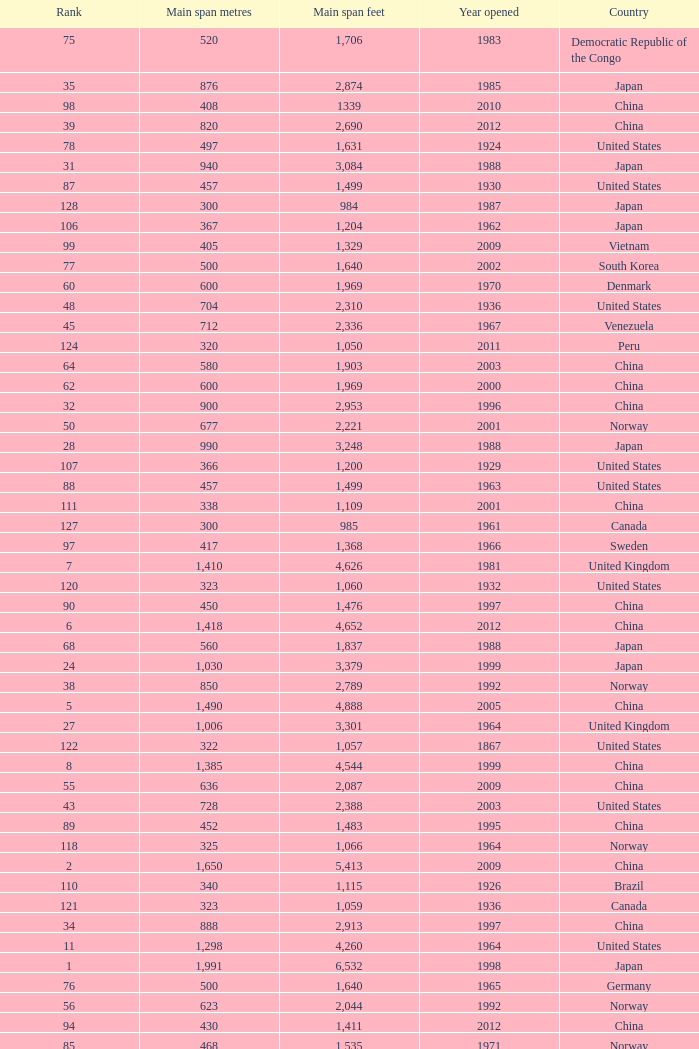Could you parse the entire table as a dict? {'header': ['Rank', 'Main span metres', 'Main span feet', 'Year opened', 'Country'], 'rows': [['75', '520', '1,706', '1983', 'Democratic Republic of the Congo'], ['35', '876', '2,874', '1985', 'Japan'], ['98', '408', '1339', '2010', 'China'], ['39', '820', '2,690', '2012', 'China'], ['78', '497', '1,631', '1924', 'United States'], ['31', '940', '3,084', '1988', 'Japan'], ['87', '457', '1,499', '1930', 'United States'], ['128', '300', '984', '1987', 'Japan'], ['106', '367', '1,204', '1962', 'Japan'], ['99', '405', '1,329', '2009', 'Vietnam'], ['77', '500', '1,640', '2002', 'South Korea'], ['60', '600', '1,969', '1970', 'Denmark'], ['48', '704', '2,310', '1936', 'United States'], ['45', '712', '2,336', '1967', 'Venezuela'], ['124', '320', '1,050', '2011', 'Peru'], ['64', '580', '1,903', '2003', 'China'], ['62', '600', '1,969', '2000', 'China'], ['32', '900', '2,953', '1996', 'China'], ['50', '677', '2,221', '2001', 'Norway'], ['28', '990', '3,248', '1988', 'Japan'], ['107', '366', '1,200', '1929', 'United States'], ['88', '457', '1,499', '1963', 'United States'], ['111', '338', '1,109', '2001', 'China'], ['127', '300', '985', '1961', 'Canada'], ['97', '417', '1,368', '1966', 'Sweden'], ['7', '1,410', '4,626', '1981', 'United Kingdom'], ['120', '323', '1,060', '1932', 'United States'], ['90', '450', '1,476', '1997', 'China'], ['6', '1,418', '4,652', '2012', 'China'], ['68', '560', '1,837', '1988', 'Japan'], ['24', '1,030', '3,379', '1999', 'Japan'], ['38', '850', '2,789', '1992', 'Norway'], ['5', '1,490', '4,888', '2005', 'China'], ['27', '1,006', '3,301', '1964', 'United Kingdom'], ['122', '322', '1,057', '1867', 'United States'], ['8', '1,385', '4,544', '1999', 'China'], ['55', '636', '2,087', '2009', 'China'], ['43', '728', '2,388', '2003', 'United States'], ['89', '452', '1,483', '1995', 'China'], ['118', '325', '1,066', '1964', 'Norway'], ['2', '1,650', '5,413', '2009', 'China'], ['110', '340', '1,115', '1926', 'Brazil'], ['121', '323', '1,059', '1936', 'Canada'], ['34', '888', '2,913', '1997', 'China'], ['11', '1,298', '4,260', '1964', 'United States'], ['1', '1,991', '6,532', '1998', 'Japan'], ['76', '500', '1,640', '1965', 'Germany'], ['56', '623', '2,044', '1992', 'Norway'], ['94', '430', '1,411', '2012', 'China'], ['85', '468', '1,535', '1971', 'Norway'], ['63', '595', '1,952', '1997', 'Norway'], ['125', '315', '1,033', '1951', 'Germany'], ['30', '960', '3,150', '2001', 'China'], ['14', '1,210', '3,970', '1997', 'Sweden'], ['92', '446', '1,463', '1997', 'Norway'], ['57', '616', '2,021', '2009', 'China'], ['113', '337', '1,106', '1956', 'Norway'], ['84', '473', '1,552', '1938', 'Canada'], ['102', '390', '1,280', '1964', 'Uzbekistan'], ['130', '300', '984', '2000', 'South Korea'], ['104', '378', '1,240', '1954', 'Germany'], ['41', '750', '2,461', '2000', 'Japan'], ['123', '320', '1,050', '1971', 'United States'], ['86', '465', '1,526', '1977', 'Japan'], ['61', '600', '1,969', '1999', 'Japan'], ['23', '1,067', '3,501', '1931', 'United States'], ['46', '712', '2,336', '1973', 'Japan'], ['42', '750', '2,461', '2000', 'Kazakhstan'], ['3', '1,624', '5,328', '1998', 'Denmark'], ['119', '325', '1,066', '1981', 'Norway'], ['4', '1,545', '5,069', '2012', 'South Korea'], ['26', '1,013', '3,323', '1966', 'Portugal'], ['16', '1,158', '3,799', '1957', 'United States'], ['109', '350', '1,148', '2006', 'China'], ['72', '534', '1,752', '1926', 'United States'], ['18', '1,100', '3,609', '1989', 'Japan'], ['52', '656', '2,152', '1968', 'United States'], ['58', '610', '2,001', '1957', 'United States'], ['19', '1,090', '3,576', '1988', 'Turkey'], ['33', '900', '2,953', '2009', 'China'], ['71', '540', '1,772', '2008', 'Japan'], ['44', '720', '2,362', '1998', 'Japan'], ['29', '988', '3,241', '1966', 'United Kingdom'], ['9', '1,377', '4,518', '1997', 'Hong Kong'], ['10', '1,310', '4,298', '2013', 'Norway'], ['70', '549', '1,801', '1961', 'United States'], ['17', '1,108', '3,635', '2008', 'China'], ['40', '770', '2,526', '1983', 'Japan'], ['116', '329', '1,088', '1939', 'United States'], ['51', '668', '2,192', '1969', 'Canada'], ['129', '300', '984', '2000', 'France'], ['93', '441', '1,447', '1955', 'Canada'], ['25', '1,020', '3,346', '1999', 'Japan'], ['105', '368', '1,207', '1931', 'United States'], ['103', '385', '1,263', '2013', 'United States'], ['112', '338', '1,108', '1965', 'United States'], ['67', '564', '1,850', '1929', 'United States Canada'], ['20', '1,088', '3,570', '2009', 'China'], ['54', '648', '2,126', '1999', 'China'], ['91', '448', '1,470', '1909', 'United States'], ['81', '488', '1,601', '1952', 'United States'], ['15', '1,176', '3,858', '2012', 'China'], ['115', '335', '1,100', '2006', 'Norway'], ['80', '488', '1,601', '1969', 'United States'], ['22', '1,074', '3,524', '1973', 'Turkey'], ['49', '701', '2,300', '1939', 'United States'], ['53', '656', '2152', '1951', 'United States'], ['69', '560', '1,837', '2001', 'China'], ['108', '351', '1,151', '1960', 'United States Canada'], ['12', '1,280', '4,200', '1937', 'United States'], ['66', '570', '1,870', '1993', 'Japan'], ['114', '335', '1,100', '1961', 'United Kingdom'], ['74', '525', '1,722', '1977', 'Norway'], ['100', '404', '1,325', '1973', 'South Korea'], ['117', '328', '1,085', '1939', 'Zambia Zimbabwe'], ['101', '394', '1,293', '1967', 'France'], ['82', '488', '1,601', '1973', 'United States'], ['95', '427', '1,401', '1970', 'Canada'], ['83', '486', '1,594', '1883', 'United States'], ['36', '853', '2,799', '1950', 'United States'], ['73', '525', '1,722', '1972', 'Norway'], ['47', '704', '2,310', '1936', 'United States'], ['21', '1,080 (x2)', '3,543 (x2)', '2012', 'China'], ['96', '421', '1,381', '1936', 'United States'], ['126', '308', '1,010', '1849', 'United States'], ['13', '1,280', '4,199', '2007', 'China'], ['37', '853', '2,799', '2007', 'United States'], ['59', '608', '1,995', '1959', 'France'], ['65', '577', '1,893', '2001', 'Norway'], ['79', '488', '1,601', '1903', 'United States']]} What is the main span feet from opening year of 1936 in the United States with a rank greater than 47 and 421 main span metres? 1381.0. 